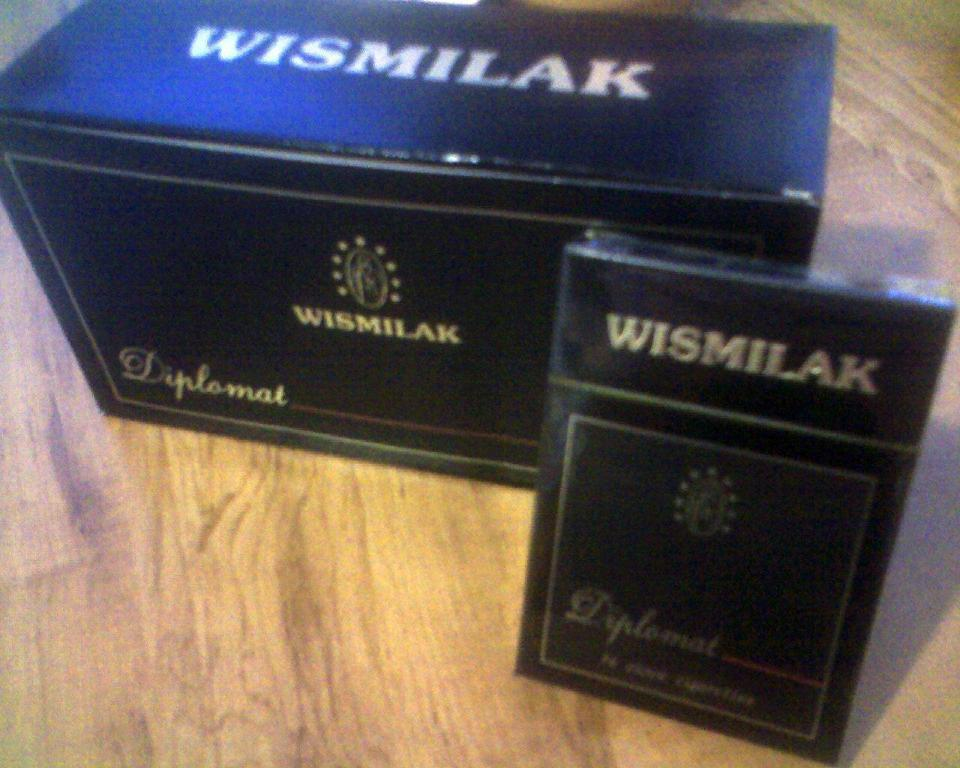<image>
Render a clear and concise summary of the photo. Black box that says Wismilak and also the word Diplomat on the bottom. 